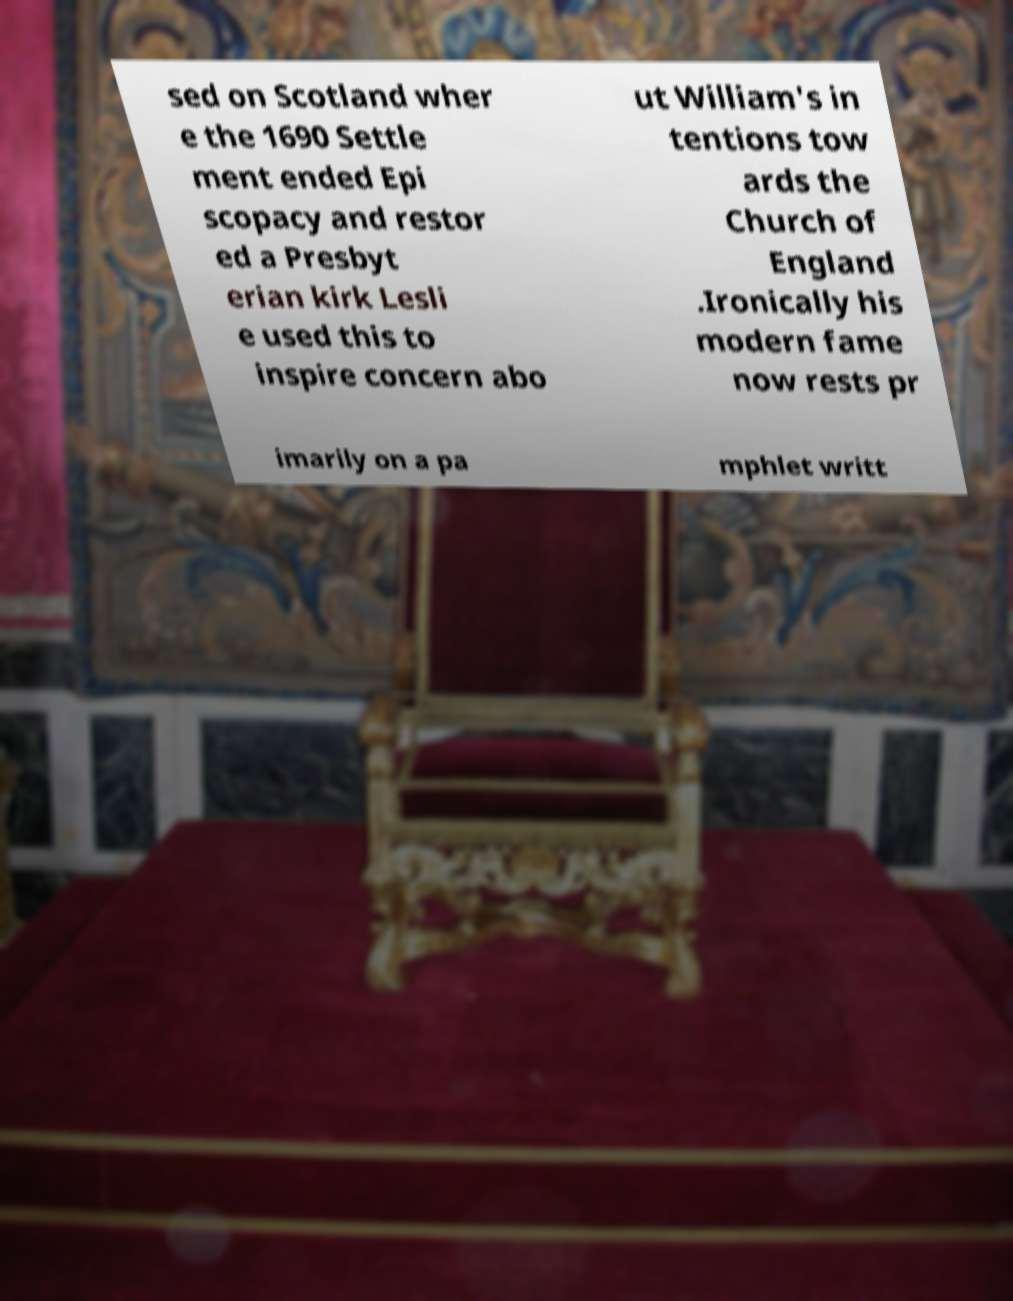I need the written content from this picture converted into text. Can you do that? sed on Scotland wher e the 1690 Settle ment ended Epi scopacy and restor ed a Presbyt erian kirk Lesli e used this to inspire concern abo ut William's in tentions tow ards the Church of England .Ironically his modern fame now rests pr imarily on a pa mphlet writt 